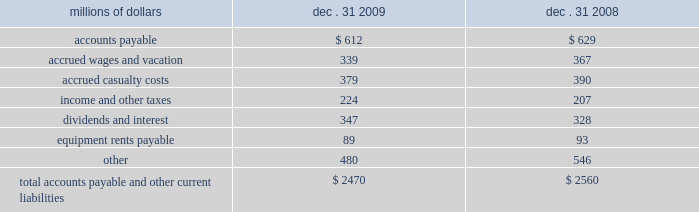Unusual , ( ii ) is material in amount , and ( iii ) varies significantly from the retirement profile identified through our depreciation studies .
A gain or loss is recognized in other income when we sell land or dispose of assets that are not part of our railroad operations .
When we purchase an asset , we capitalize all costs necessary to make the asset ready for its intended use .
However , many of our assets are self-constructed .
A large portion of our capital expenditures is for replacement of existing road infrastructure assets ( program projects ) , which is typically performed by our employees , and for track line expansion ( capacity projects ) .
Costs that are directly attributable or overhead costs that relate directly to capital projects are capitalized .
Direct costs that are capitalized as part of self-constructed assets include material , labor , and work equipment .
Indirect costs are capitalized if they clearly relate to the construction of the asset .
These costs are allocated using appropriate statistical bases .
General and administrative expenditures are expensed as incurred .
Normal repairs and maintenance are also expensed as incurred , while costs incurred that extend the useful life of an asset , improve the safety of our operations or improve operating efficiency are capitalized .
Assets held under capital leases are recorded at the lower of the net present value of the minimum lease payments or the fair value of the leased asset at the inception of the lease .
Amortization expense is computed using the straight-line method over the shorter of the estimated useful lives of the assets or the period of the related lease .
11 .
Accounts payable and other current liabilities dec .
31 , dec .
31 , millions of dollars 2009 2008 .
12 .
Financial instruments strategy and risk 2013 we may use derivative financial instruments in limited instances for other than trading purposes to assist in managing our overall exposure to fluctuations in interest rates and fuel prices .
We are not a party to leveraged derivatives and , by policy , do not use derivative financial instruments for speculative purposes .
Derivative financial instruments qualifying for hedge accounting must maintain a specified level of effectiveness between the hedging instrument and the item being hedged , both at inception and throughout the hedged period .
We formally document the nature and relationships between the hedging instruments and hedged items at inception , as well as our risk-management objectives , strategies for undertaking the various hedge transactions , and method of assessing hedge effectiveness .
Changes in the fair market value of derivative financial instruments that do not qualify for hedge accounting are charged to earnings .
We may use swaps , collars , futures , and/or forward contracts to mitigate the risk of adverse movements in interest rates and fuel prices ; however , the use of these derivative financial instruments may limit future benefits from favorable interest rate and fuel price movements. .
For 2009 , what is the proportion of equipment rents payable of the total accounts payable? 
Computations: (89 / 2470)
Answer: 0.03603. 